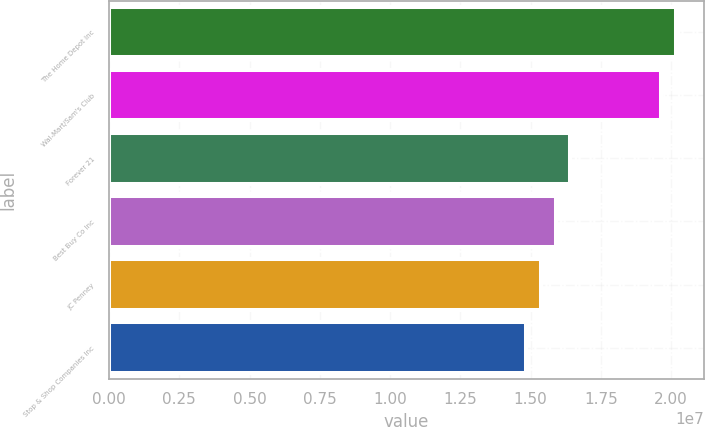<chart> <loc_0><loc_0><loc_500><loc_500><bar_chart><fcel>The Home Depot Inc<fcel>Wal-Mart/Sam's Club<fcel>Forever 21<fcel>Best Buy Co Inc<fcel>JC Penney<fcel>Stop & Shop Companies Inc<nl><fcel>2.01584e+07<fcel>1.964e+07<fcel>1.64082e+07<fcel>1.58898e+07<fcel>1.53714e+07<fcel>1.4853e+07<nl></chart> 